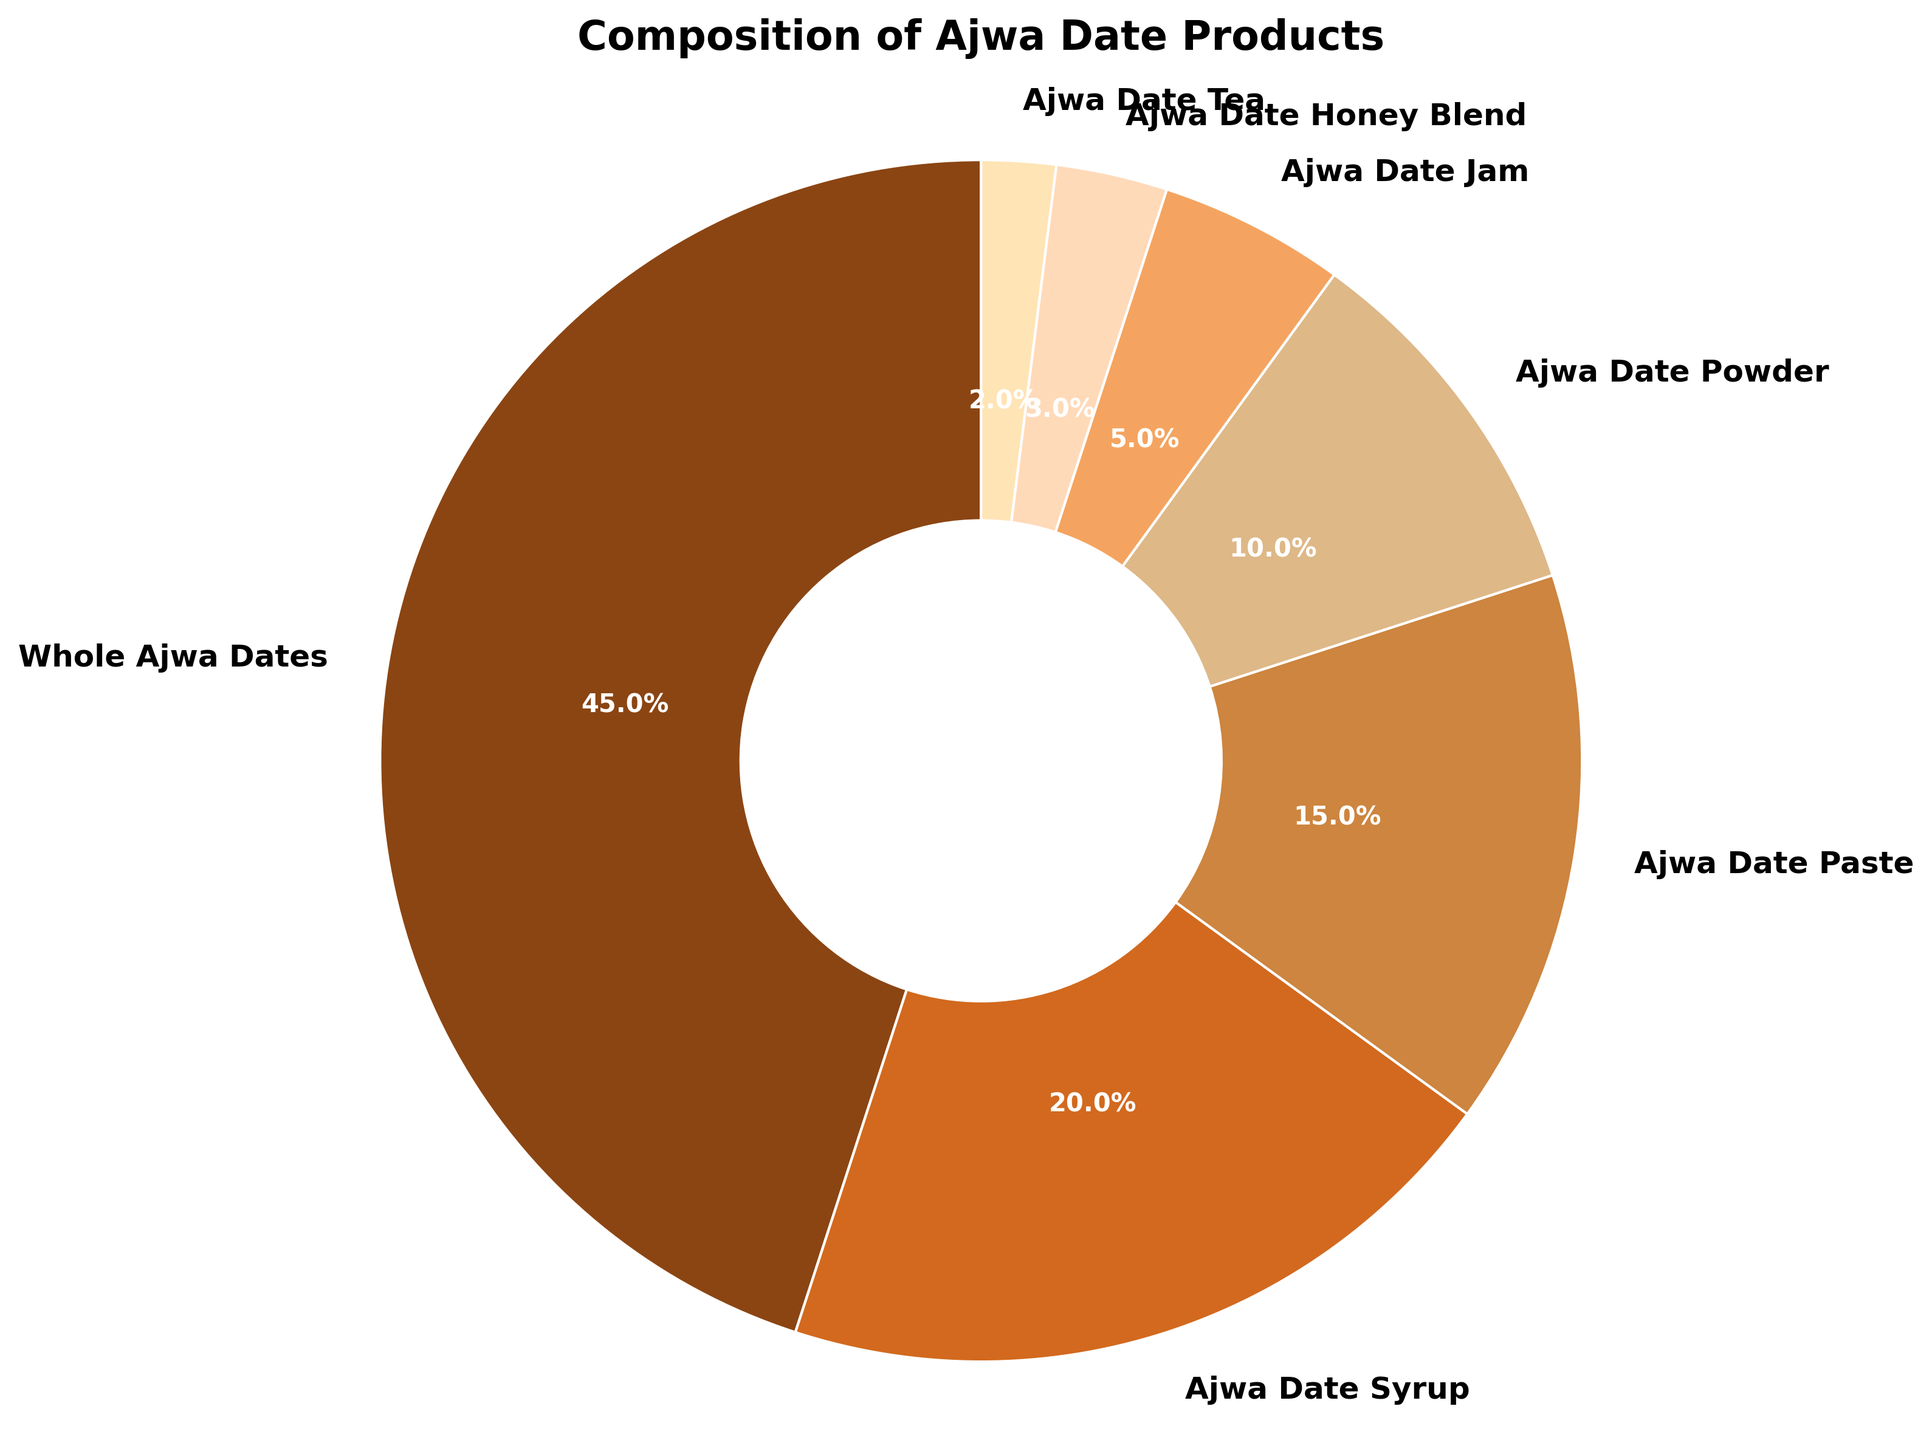What percentage of the total is contributed by the combined amounts of Whole Ajwa Dates and Ajwa Date Syrup? First, note that Whole Ajwa Dates have 45%, and Ajwa Date Syrup has 20%. Adding these together, 45% + 20% = 65%.
Answer: 65% Which product has the lowest percentage composition? According to the pie chart, Ajwa Date Tea has the smallest slice, indicating it has the lowest percentage of 2%.
Answer: Ajwa Date Tea What is the difference in percentage between Ajwa Date Paste and Ajwa Date Powder? Ajwa Date Paste has 15%, while Ajwa Date Powder has 10%. The difference is calculated as 15% - 10% = 5%.
Answer: 5% Is Ajwa Date Syrup's percentage greater than the combined total of Ajwa Date Jam and Ajwa Date Honey Blend? Ajwa Date Syrup has 20%. Ajwa Date Jam and Ajwa Date Honey Blend together have 5% + 3% = 8%. Since 20% > 8%, Ajwa Date Syrup's percentage is indeed greater.
Answer: Yes Which product group is represented by the largest portion of the pie chart? The largest portion corresponds to Whole Ajwa Dates, occupying 45% of the pie chart.
Answer: Whole Ajwa Dates What is the combined percentage of the products that constitute less than 10% each? Ajwa Date Jam (5%), Ajwa Date Honey Blend (3%), and Ajwa Date Tea (2%) together make up 5% + 3% + 2% = 10% of the chart.
Answer: 10% How many product categories account for more than 15% each? By examining the chart, we see that only Whole Ajwa Dates (45%) and Ajwa Date Syrup (20%) each account for more than 15%. There are 2 such categories.
Answer: 2 What percentage of the pie chart is represented by products other than Whole Ajwa Dates? Whole Ajwa Dates take up 45%. The remaining part is 100% - 45% = 55%.
Answer: 55% Are there more products that each make up less than 5% or more than 5%? Ajwa Date Jam (5%), Ajwa Date Honey Blend (3%), and Ajwa Date Tea (2%) each make up less than 5%, totaling 3 products. Whole Ajwa Dates (45%), Ajwa Date Syrup (20%), Ajwa Date Paste (15%), and Ajwa Date Powder (10%) each account for more than 5%, totaling 4 products. Thus, there are more products making up more than 5% of the pie chart.
Answer: More products make up more than 5% Which two products together constitute the same percentage as Whole Ajwa Dates? Whole Ajwa Dates are 45%. Ajwa Date Syrup (20%) and Ajwa Date Paste (15%) together account for 20% + 15% = 35%. We need to add another product like Ajwa Date Powder (10%), reaching 35% + 10% = 45%. Therefore, Ajwa Date Syrup, Ajwa Date Paste, and Ajwa Date Powder together constitute the same percentage as Whole Ajwa Dates. However, if we look for just two products, it is not possible.
Answer: Not possible with just two products 